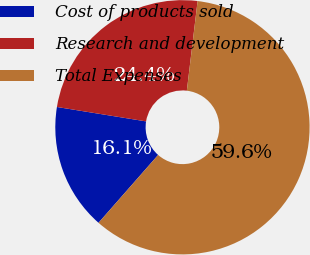Convert chart. <chart><loc_0><loc_0><loc_500><loc_500><pie_chart><fcel>Cost of products sold<fcel>Research and development<fcel>Total Expenses<nl><fcel>16.08%<fcel>24.35%<fcel>59.57%<nl></chart> 